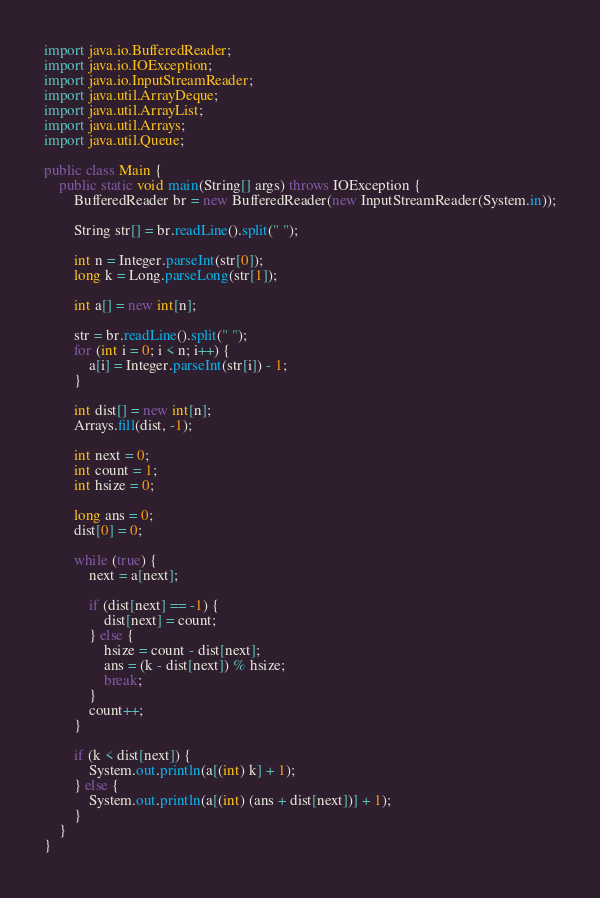Convert code to text. <code><loc_0><loc_0><loc_500><loc_500><_Java_>import java.io.BufferedReader;
import java.io.IOException;
import java.io.InputStreamReader;
import java.util.ArrayDeque;
import java.util.ArrayList;
import java.util.Arrays;
import java.util.Queue;

public class Main {
	public static void main(String[] args) throws IOException {
		BufferedReader br = new BufferedReader(new InputStreamReader(System.in));

		String str[] = br.readLine().split(" ");

		int n = Integer.parseInt(str[0]);
		long k = Long.parseLong(str[1]);

		int a[] = new int[n];

		str = br.readLine().split(" ");
		for (int i = 0; i < n; i++) {
			a[i] = Integer.parseInt(str[i]) - 1;
		}

		int dist[] = new int[n];
		Arrays.fill(dist, -1);

		int next = 0;
		int count = 1;
		int hsize = 0;

		long ans = 0;
		dist[0] = 0;

		while (true) {
			next = a[next];

			if (dist[next] == -1) {
				dist[next] = count;
			} else {
				hsize = count - dist[next];
				ans = (k - dist[next]) % hsize;
				break;
			}
			count++;
		}

		if (k < dist[next]) {
			System.out.println(a[(int) k] + 1);
		} else {
			System.out.println(a[(int) (ans + dist[next])] + 1);
		}
	}
}
</code> 